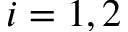<formula> <loc_0><loc_0><loc_500><loc_500>i = 1 , 2</formula> 